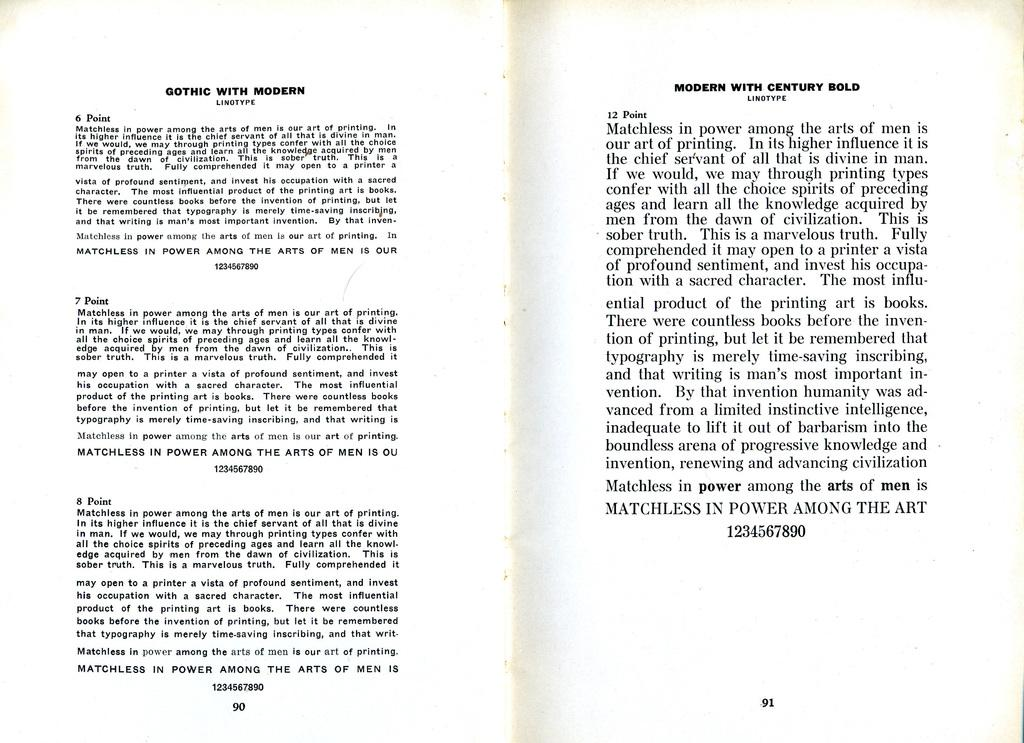<image>
Provide a brief description of the given image. The book discusses support for Gothic with modern linotype. 